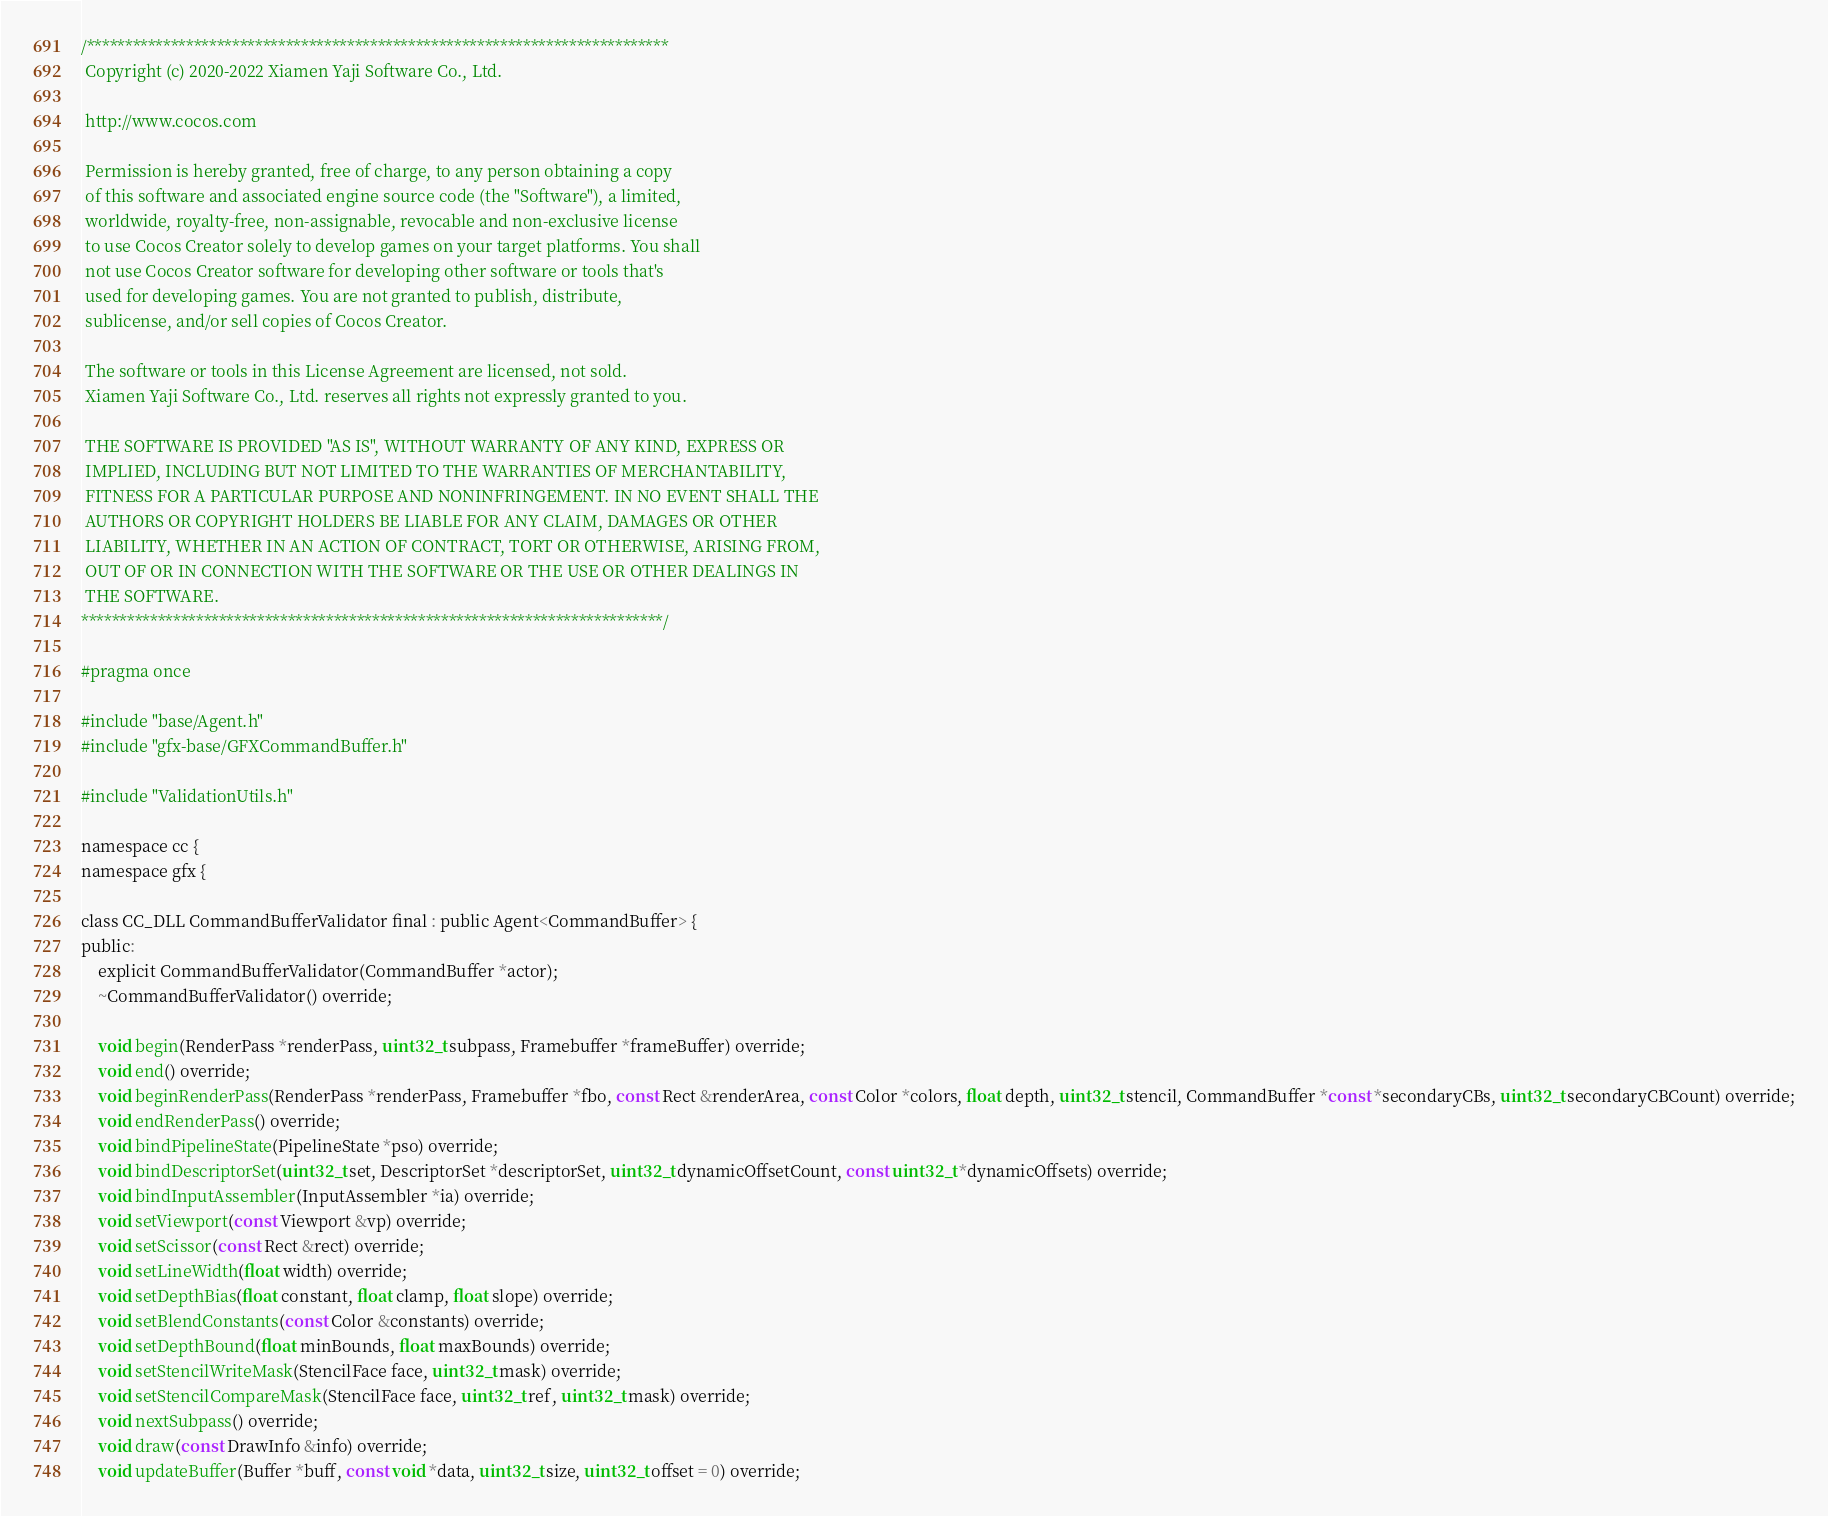<code> <loc_0><loc_0><loc_500><loc_500><_C_>/****************************************************************************
 Copyright (c) 2020-2022 Xiamen Yaji Software Co., Ltd.

 http://www.cocos.com

 Permission is hereby granted, free of charge, to any person obtaining a copy
 of this software and associated engine source code (the "Software"), a limited,
 worldwide, royalty-free, non-assignable, revocable and non-exclusive license
 to use Cocos Creator solely to develop games on your target platforms. You shall
 not use Cocos Creator software for developing other software or tools that's
 used for developing games. You are not granted to publish, distribute,
 sublicense, and/or sell copies of Cocos Creator.

 The software or tools in this License Agreement are licensed, not sold.
 Xiamen Yaji Software Co., Ltd. reserves all rights not expressly granted to you.

 THE SOFTWARE IS PROVIDED "AS IS", WITHOUT WARRANTY OF ANY KIND, EXPRESS OR
 IMPLIED, INCLUDING BUT NOT LIMITED TO THE WARRANTIES OF MERCHANTABILITY,
 FITNESS FOR A PARTICULAR PURPOSE AND NONINFRINGEMENT. IN NO EVENT SHALL THE
 AUTHORS OR COPYRIGHT HOLDERS BE LIABLE FOR ANY CLAIM, DAMAGES OR OTHER
 LIABILITY, WHETHER IN AN ACTION OF CONTRACT, TORT OR OTHERWISE, ARISING FROM,
 OUT OF OR IN CONNECTION WITH THE SOFTWARE OR THE USE OR OTHER DEALINGS IN
 THE SOFTWARE.
****************************************************************************/

#pragma once

#include "base/Agent.h"
#include "gfx-base/GFXCommandBuffer.h"

#include "ValidationUtils.h"

namespace cc {
namespace gfx {

class CC_DLL CommandBufferValidator final : public Agent<CommandBuffer> {
public:
    explicit CommandBufferValidator(CommandBuffer *actor);
    ~CommandBufferValidator() override;

    void begin(RenderPass *renderPass, uint32_t subpass, Framebuffer *frameBuffer) override;
    void end() override;
    void beginRenderPass(RenderPass *renderPass, Framebuffer *fbo, const Rect &renderArea, const Color *colors, float depth, uint32_t stencil, CommandBuffer *const *secondaryCBs, uint32_t secondaryCBCount) override;
    void endRenderPass() override;
    void bindPipelineState(PipelineState *pso) override;
    void bindDescriptorSet(uint32_t set, DescriptorSet *descriptorSet, uint32_t dynamicOffsetCount, const uint32_t *dynamicOffsets) override;
    void bindInputAssembler(InputAssembler *ia) override;
    void setViewport(const Viewport &vp) override;
    void setScissor(const Rect &rect) override;
    void setLineWidth(float width) override;
    void setDepthBias(float constant, float clamp, float slope) override;
    void setBlendConstants(const Color &constants) override;
    void setDepthBound(float minBounds, float maxBounds) override;
    void setStencilWriteMask(StencilFace face, uint32_t mask) override;
    void setStencilCompareMask(StencilFace face, uint32_t ref, uint32_t mask) override;
    void nextSubpass() override;
    void draw(const DrawInfo &info) override;
    void updateBuffer(Buffer *buff, const void *data, uint32_t size, uint32_t offset = 0) override;</code> 